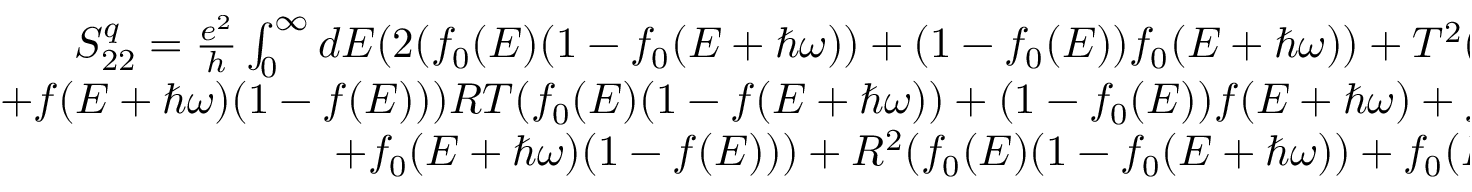Convert formula to latex. <formula><loc_0><loc_0><loc_500><loc_500>\begin{array} { r } { S _ { 2 2 } ^ { q } = \frac { e ^ { 2 } } { h } \int _ { 0 } ^ { \infty } d E ( 2 ( f _ { 0 } ( E ) ( 1 - f _ { 0 } ( E + \hbar { \omega } ) ) + ( 1 - f _ { 0 } ( E ) ) f _ { 0 } ( E + \hbar { \omega } ) ) + T ^ { 2 } ( f ( E ) ( 1 - f ( E + \hbar { \omega } ) ) } \\ { + f ( E + \hbar { \omega } ) ( 1 - f ( E ) ) ) R T ( f _ { 0 } ( E ) ( 1 - f ( E + \hbar { \omega } ) ) + ( 1 - f _ { 0 } ( E ) ) f ( E + \hbar { \omega } ) + f ( E ) ( 1 - f _ { 0 } ( E + \hbar { \omega } ) ) } \\ { + f _ { 0 } ( E + \hbar { \omega } ) ( 1 - f ( E ) ) ) + R ^ { 2 } ( f _ { 0 } ( E ) ( 1 - f _ { 0 } ( E + \hbar { \omega } ) ) + f _ { 0 } ( E + \hbar { \omega } ) ( 1 - f _ { 0 } ( E ) ) ) ) . } \end{array}</formula> 